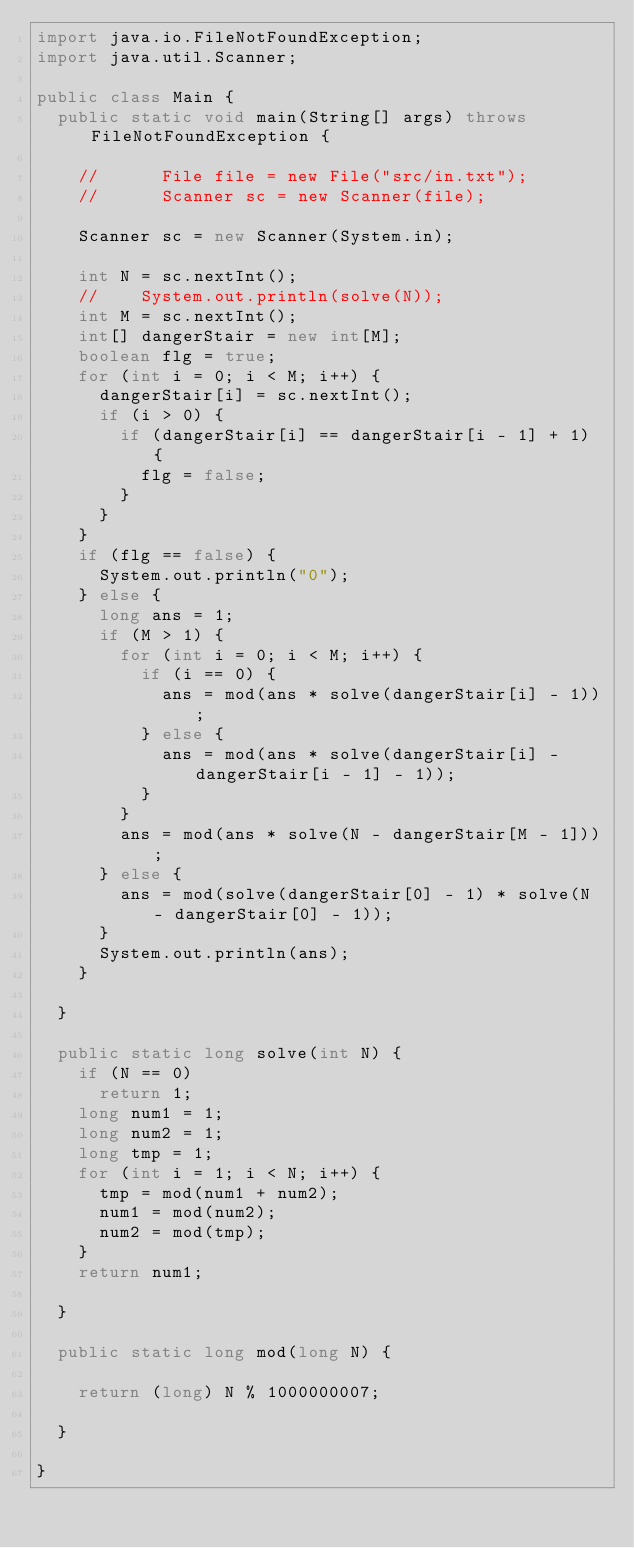<code> <loc_0><loc_0><loc_500><loc_500><_Java_>import java.io.FileNotFoundException;
import java.util.Scanner;

public class Main {
	public static void main(String[] args) throws FileNotFoundException {

		//    	File file = new File("src/in.txt");
		//    	Scanner sc = new Scanner(file);

		Scanner sc = new Scanner(System.in);

		int N = sc.nextInt();
		//		System.out.println(solve(N));
		int M = sc.nextInt();
		int[] dangerStair = new int[M];
		boolean flg = true;
		for (int i = 0; i < M; i++) {
			dangerStair[i] = sc.nextInt();
			if (i > 0) {
				if (dangerStair[i] == dangerStair[i - 1] + 1) {
					flg = false;
				}
			}
		}
		if (flg == false) {
			System.out.println("0");
		} else {
			long ans = 1;
			if (M > 1) {
				for (int i = 0; i < M; i++) {
					if (i == 0) {
						ans = mod(ans * solve(dangerStair[i] - 1));
					} else {
						ans = mod(ans * solve(dangerStair[i] - dangerStair[i - 1] - 1));
					}
				}
				ans = mod(ans * solve(N - dangerStair[M - 1]));
			} else {
				ans = mod(solve(dangerStair[0] - 1) * solve(N - dangerStair[0] - 1));
			}
			System.out.println(ans);
		}

	}

	public static long solve(int N) {
		if (N == 0)
			return 1;
		long num1 = 1;
		long num2 = 1;
		long tmp = 1;
		for (int i = 1; i < N; i++) {
			tmp = mod(num1 + num2);
			num1 = mod(num2);
			num2 = mod(tmp);
		}
		return num1;

	}

	public static long mod(long N) {

		return (long) N % 1000000007;

	}

}
</code> 